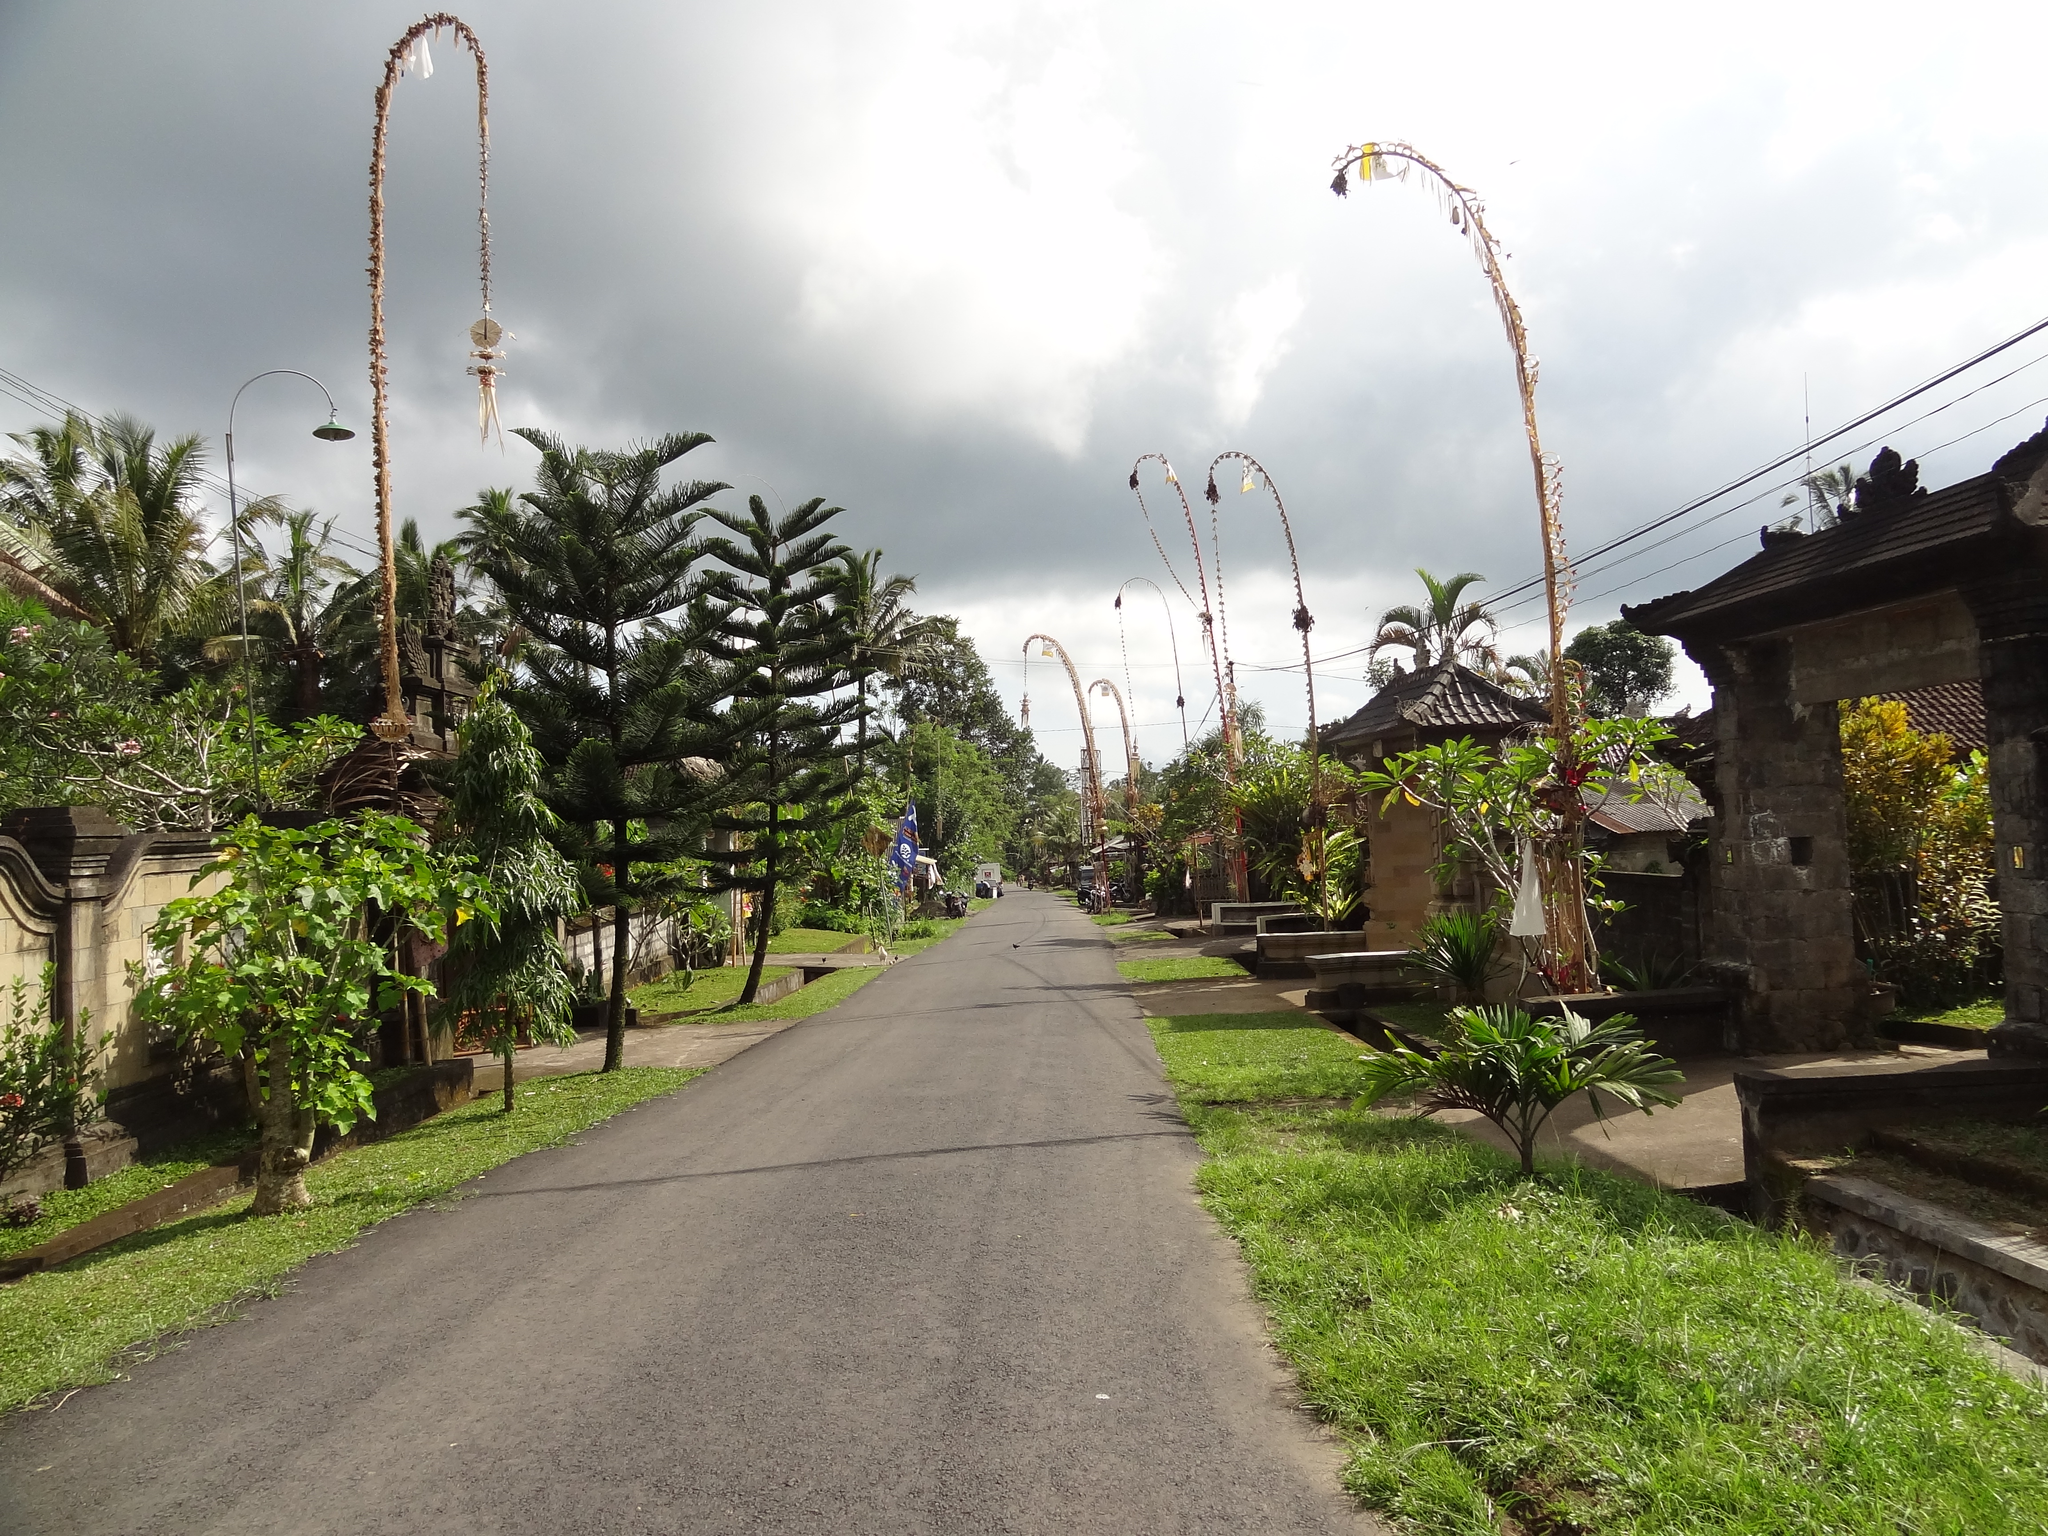Please provide a concise description of this image. In this picture we can see the sky, trees, grass, plants, wall, road and few objects. 